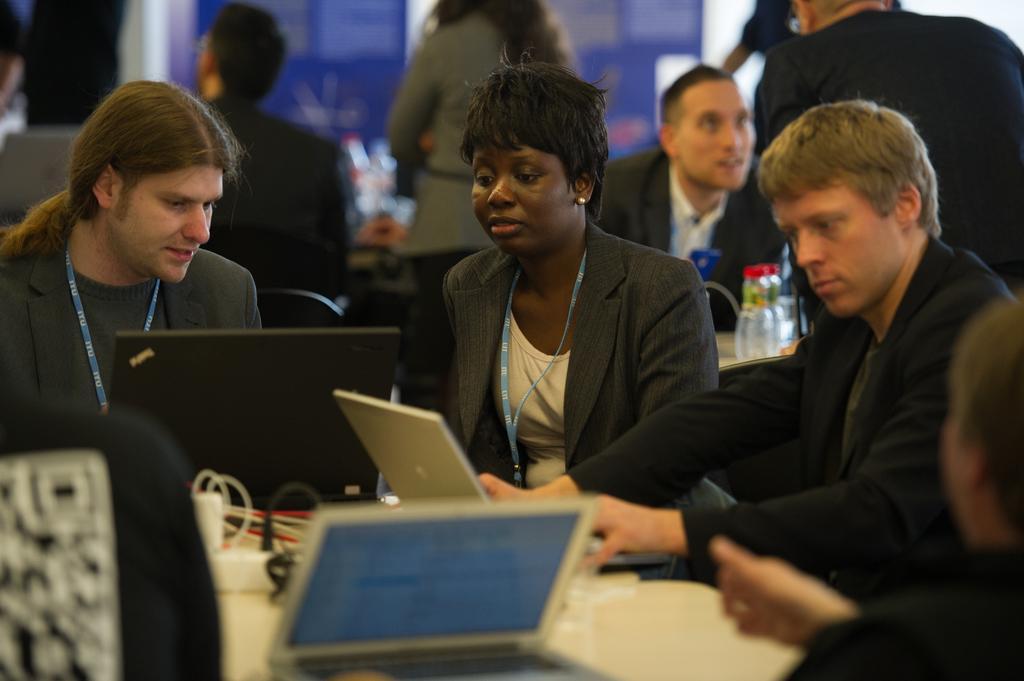Please provide a concise description of this image. In this picture I can see laptops and cables on the table, there are group of people sitting on the chairs, there are group of people standing, and there is blur background. 